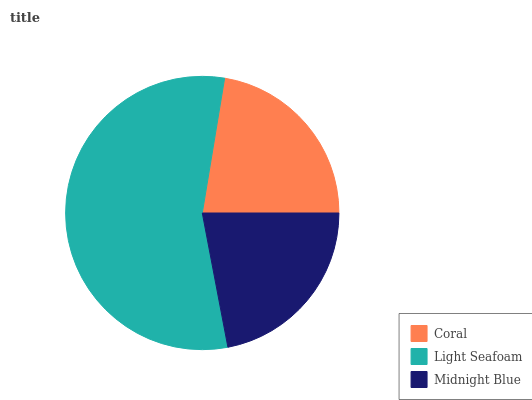Is Midnight Blue the minimum?
Answer yes or no. Yes. Is Light Seafoam the maximum?
Answer yes or no. Yes. Is Light Seafoam the minimum?
Answer yes or no. No. Is Midnight Blue the maximum?
Answer yes or no. No. Is Light Seafoam greater than Midnight Blue?
Answer yes or no. Yes. Is Midnight Blue less than Light Seafoam?
Answer yes or no. Yes. Is Midnight Blue greater than Light Seafoam?
Answer yes or no. No. Is Light Seafoam less than Midnight Blue?
Answer yes or no. No. Is Coral the high median?
Answer yes or no. Yes. Is Coral the low median?
Answer yes or no. Yes. Is Midnight Blue the high median?
Answer yes or no. No. Is Midnight Blue the low median?
Answer yes or no. No. 